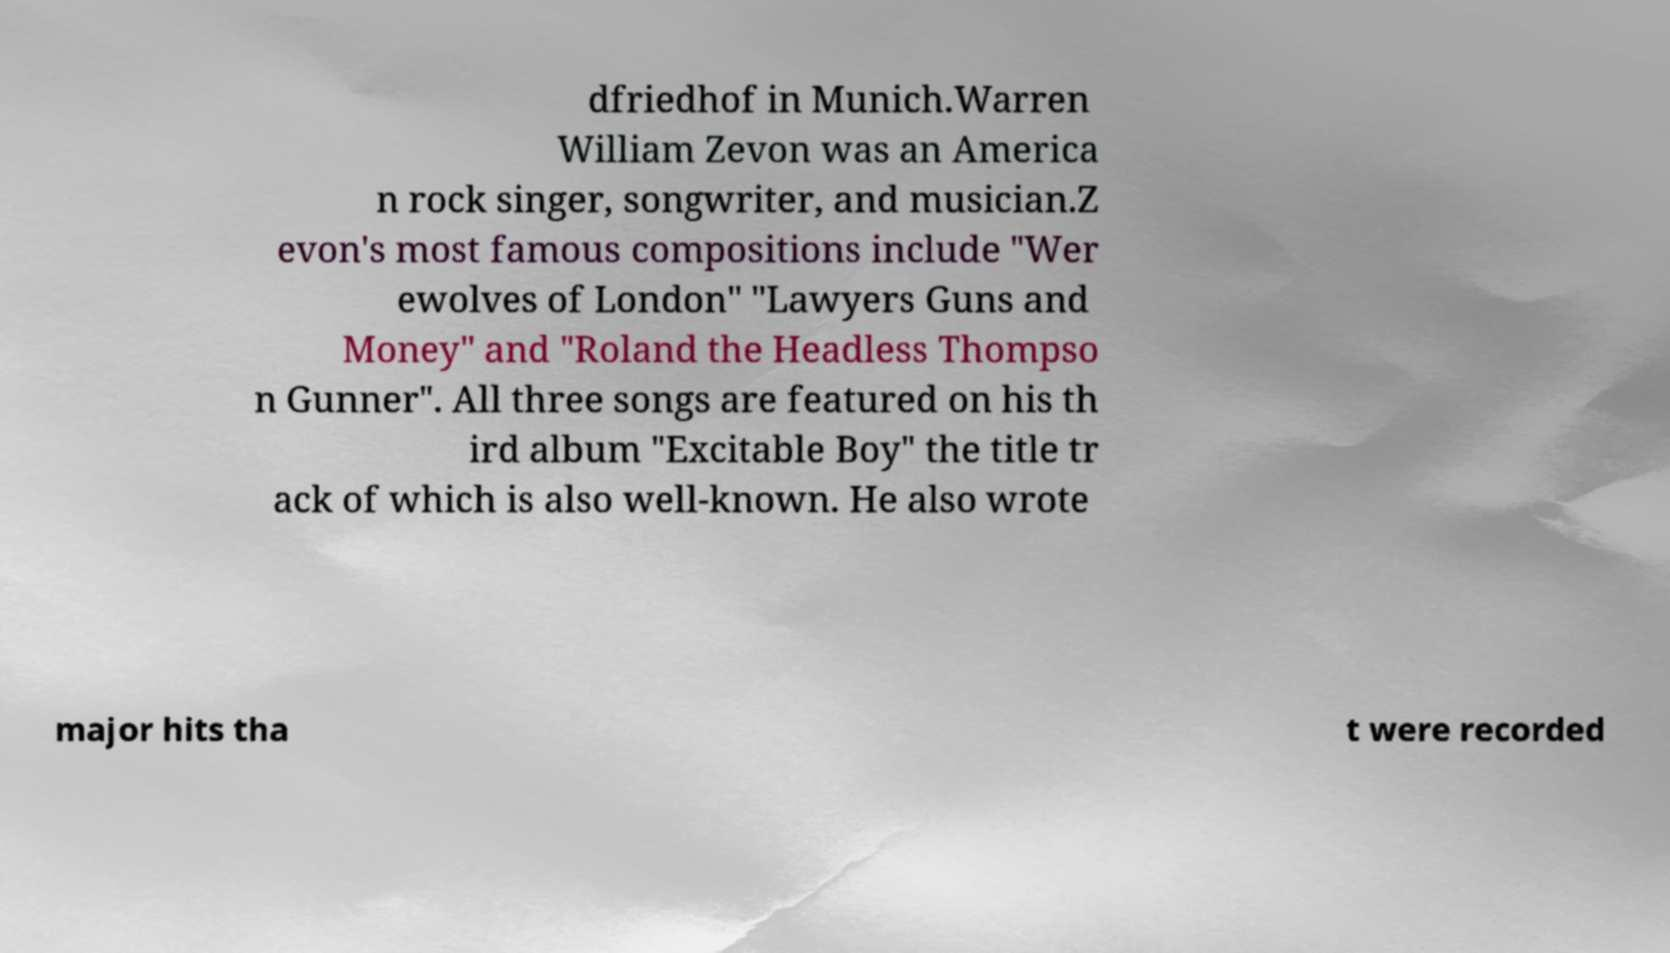Please identify and transcribe the text found in this image. dfriedhof in Munich.Warren William Zevon was an America n rock singer, songwriter, and musician.Z evon's most famous compositions include "Wer ewolves of London" "Lawyers Guns and Money" and "Roland the Headless Thompso n Gunner". All three songs are featured on his th ird album "Excitable Boy" the title tr ack of which is also well-known. He also wrote major hits tha t were recorded 